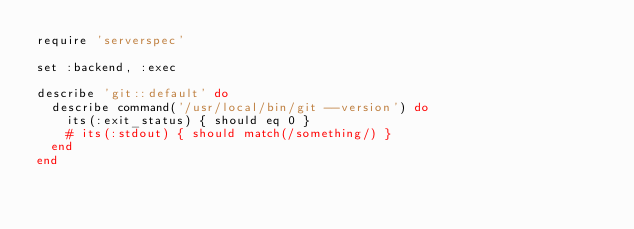Convert code to text. <code><loc_0><loc_0><loc_500><loc_500><_Ruby_>require 'serverspec'

set :backend, :exec

describe 'git::default' do
  describe command('/usr/local/bin/git --version') do
    its(:exit_status) { should eq 0 }
    # its(:stdout) { should match(/something/) }
  end
end
</code> 